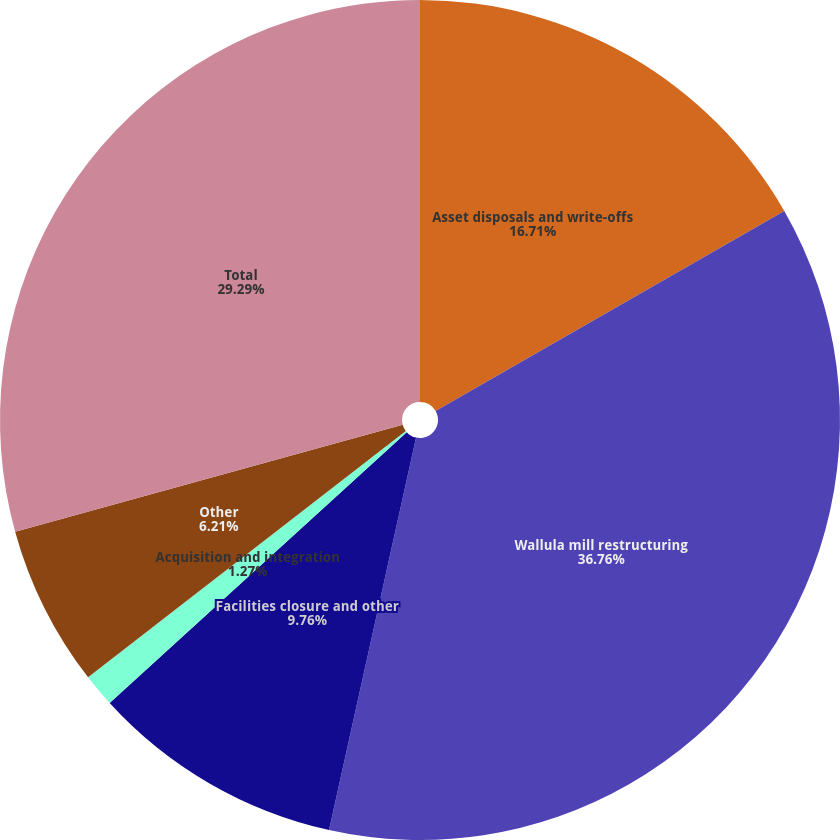<chart> <loc_0><loc_0><loc_500><loc_500><pie_chart><fcel>Asset disposals and write-offs<fcel>Wallula mill restructuring<fcel>Facilities closure and other<fcel>Acquisition and integration<fcel>Other<fcel>Total<nl><fcel>16.71%<fcel>36.77%<fcel>9.76%<fcel>1.27%<fcel>6.21%<fcel>29.29%<nl></chart> 